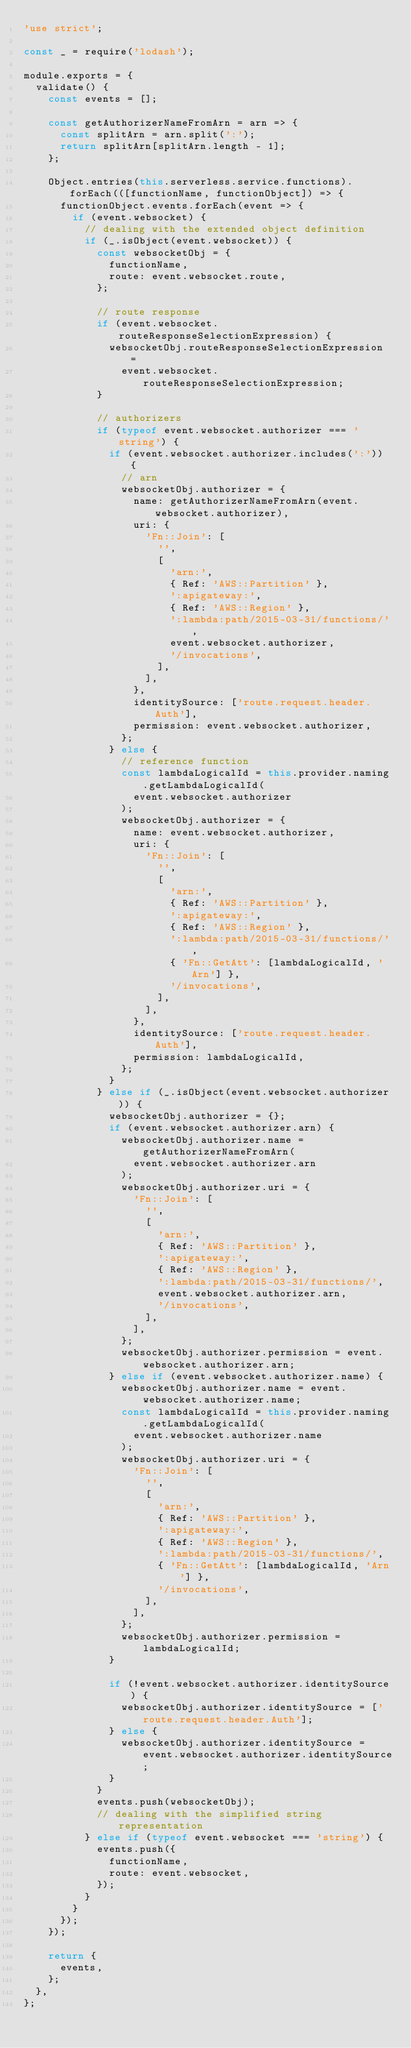<code> <loc_0><loc_0><loc_500><loc_500><_JavaScript_>'use strict';

const _ = require('lodash');

module.exports = {
  validate() {
    const events = [];

    const getAuthorizerNameFromArn = arn => {
      const splitArn = arn.split(':');
      return splitArn[splitArn.length - 1];
    };

    Object.entries(this.serverless.service.functions).forEach(([functionName, functionObject]) => {
      functionObject.events.forEach(event => {
        if (event.websocket) {
          // dealing with the extended object definition
          if (_.isObject(event.websocket)) {
            const websocketObj = {
              functionName,
              route: event.websocket.route,
            };

            // route response
            if (event.websocket.routeResponseSelectionExpression) {
              websocketObj.routeResponseSelectionExpression =
                event.websocket.routeResponseSelectionExpression;
            }

            // authorizers
            if (typeof event.websocket.authorizer === 'string') {
              if (event.websocket.authorizer.includes(':')) {
                // arn
                websocketObj.authorizer = {
                  name: getAuthorizerNameFromArn(event.websocket.authorizer),
                  uri: {
                    'Fn::Join': [
                      '',
                      [
                        'arn:',
                        { Ref: 'AWS::Partition' },
                        ':apigateway:',
                        { Ref: 'AWS::Region' },
                        ':lambda:path/2015-03-31/functions/',
                        event.websocket.authorizer,
                        '/invocations',
                      ],
                    ],
                  },
                  identitySource: ['route.request.header.Auth'],
                  permission: event.websocket.authorizer,
                };
              } else {
                // reference function
                const lambdaLogicalId = this.provider.naming.getLambdaLogicalId(
                  event.websocket.authorizer
                );
                websocketObj.authorizer = {
                  name: event.websocket.authorizer,
                  uri: {
                    'Fn::Join': [
                      '',
                      [
                        'arn:',
                        { Ref: 'AWS::Partition' },
                        ':apigateway:',
                        { Ref: 'AWS::Region' },
                        ':lambda:path/2015-03-31/functions/',
                        { 'Fn::GetAtt': [lambdaLogicalId, 'Arn'] },
                        '/invocations',
                      ],
                    ],
                  },
                  identitySource: ['route.request.header.Auth'],
                  permission: lambdaLogicalId,
                };
              }
            } else if (_.isObject(event.websocket.authorizer)) {
              websocketObj.authorizer = {};
              if (event.websocket.authorizer.arn) {
                websocketObj.authorizer.name = getAuthorizerNameFromArn(
                  event.websocket.authorizer.arn
                );
                websocketObj.authorizer.uri = {
                  'Fn::Join': [
                    '',
                    [
                      'arn:',
                      { Ref: 'AWS::Partition' },
                      ':apigateway:',
                      { Ref: 'AWS::Region' },
                      ':lambda:path/2015-03-31/functions/',
                      event.websocket.authorizer.arn,
                      '/invocations',
                    ],
                  ],
                };
                websocketObj.authorizer.permission = event.websocket.authorizer.arn;
              } else if (event.websocket.authorizer.name) {
                websocketObj.authorizer.name = event.websocket.authorizer.name;
                const lambdaLogicalId = this.provider.naming.getLambdaLogicalId(
                  event.websocket.authorizer.name
                );
                websocketObj.authorizer.uri = {
                  'Fn::Join': [
                    '',
                    [
                      'arn:',
                      { Ref: 'AWS::Partition' },
                      ':apigateway:',
                      { Ref: 'AWS::Region' },
                      ':lambda:path/2015-03-31/functions/',
                      { 'Fn::GetAtt': [lambdaLogicalId, 'Arn'] },
                      '/invocations',
                    ],
                  ],
                };
                websocketObj.authorizer.permission = lambdaLogicalId;
              }

              if (!event.websocket.authorizer.identitySource) {
                websocketObj.authorizer.identitySource = ['route.request.header.Auth'];
              } else {
                websocketObj.authorizer.identitySource = event.websocket.authorizer.identitySource;
              }
            }
            events.push(websocketObj);
            // dealing with the simplified string representation
          } else if (typeof event.websocket === 'string') {
            events.push({
              functionName,
              route: event.websocket,
            });
          }
        }
      });
    });

    return {
      events,
    };
  },
};
</code> 